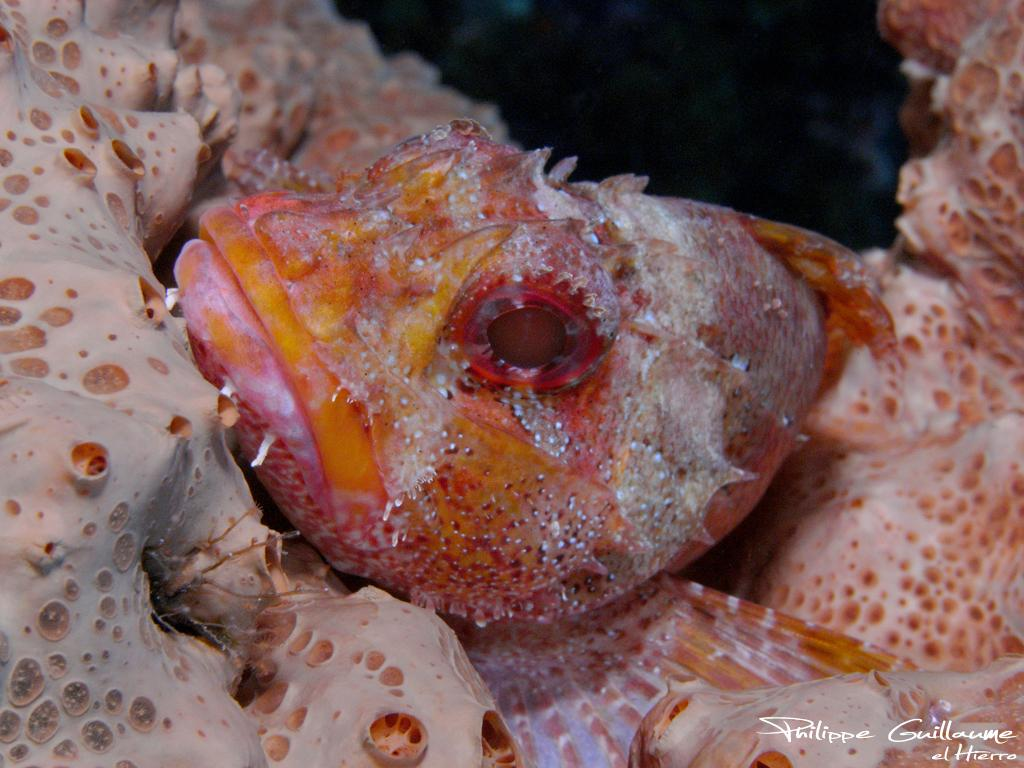What type of animals are present in the image? The image contains fishes. Can you describe one of the fishes in the image? There is an orange-colored fish in the image. What type of trucks can be seen driving through the water in the image? There are no trucks present in the image; it features fishes in water. What material is used to cover the fish in the image? The image does not show any fish being covered, nor is there any material used for covering. 